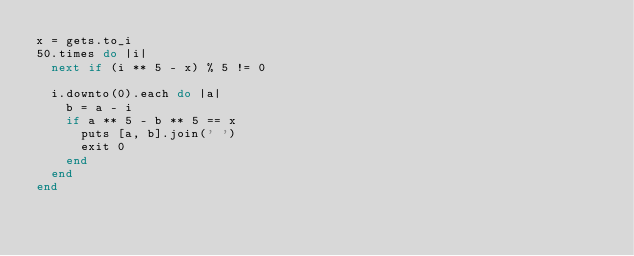<code> <loc_0><loc_0><loc_500><loc_500><_Ruby_>x = gets.to_i
50.times do |i|
  next if (i ** 5 - x) % 5 != 0

  i.downto(0).each do |a|
    b = a - i
    if a ** 5 - b ** 5 == x
      puts [a, b].join(' ')
      exit 0
    end
  end
end</code> 